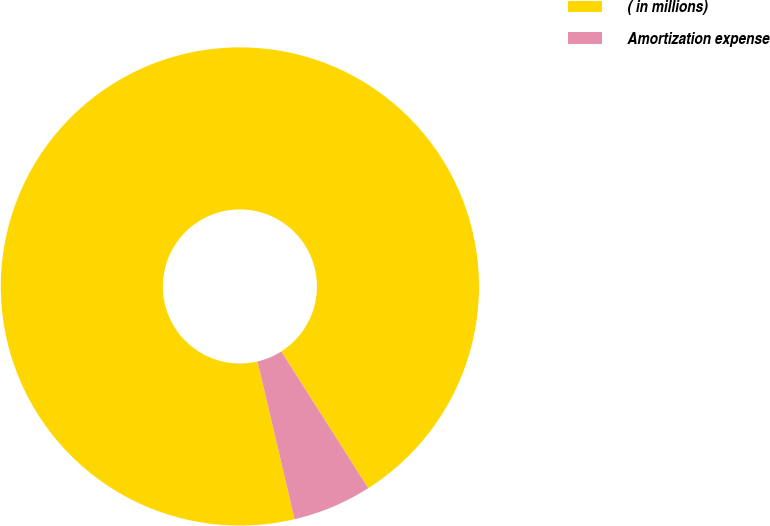<chart> <loc_0><loc_0><loc_500><loc_500><pie_chart><fcel>( in millions)<fcel>Amortization expense<nl><fcel>94.65%<fcel>5.35%<nl></chart> 